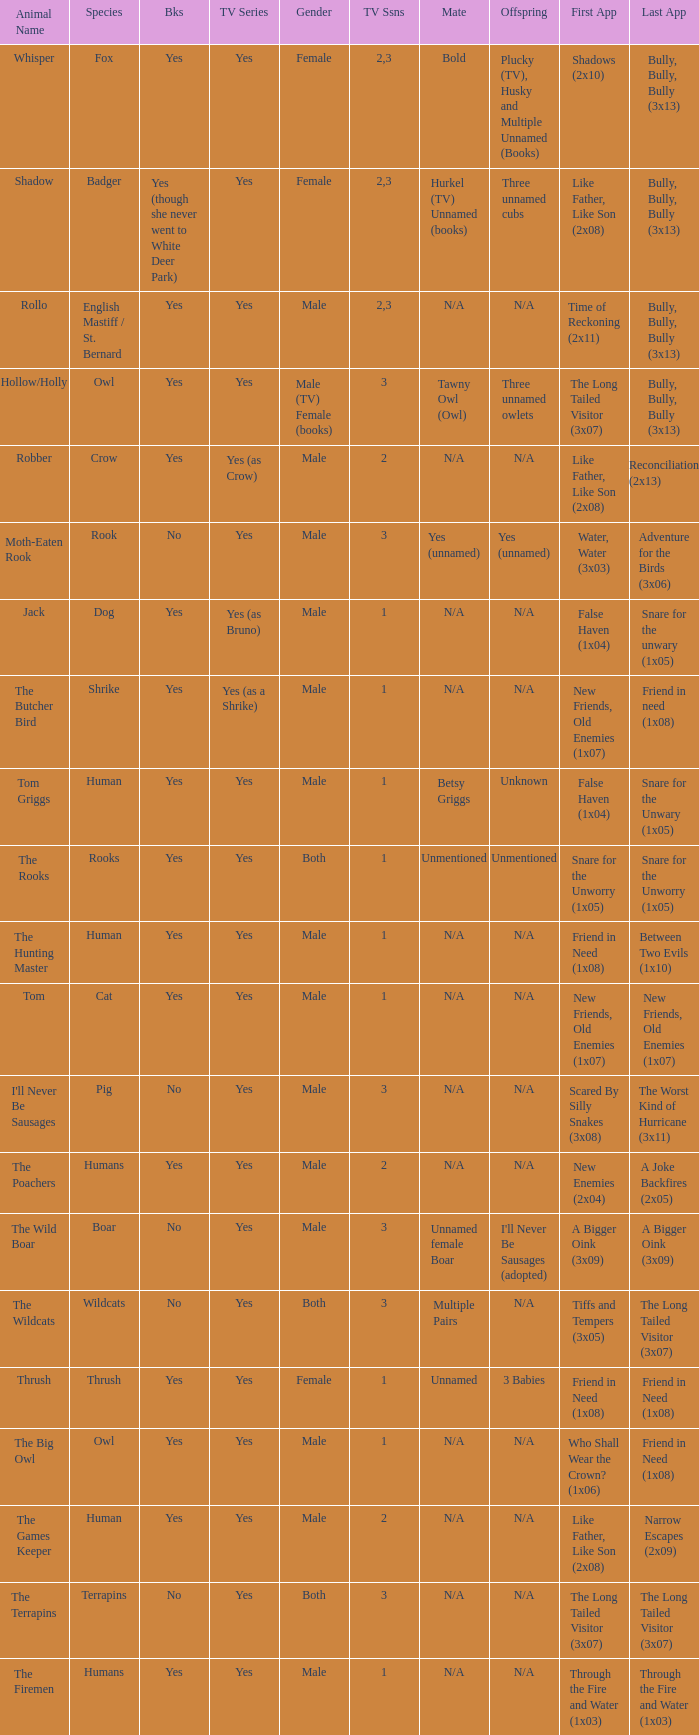I'm looking to parse the entire table for insights. Could you assist me with that? {'header': ['Animal Name', 'Species', 'Bks', 'TV Series', 'Gender', 'TV Ssns', 'Mate', 'Offspring', 'First App', 'Last App'], 'rows': [['Whisper', 'Fox', 'Yes', 'Yes', 'Female', '2,3', 'Bold', 'Plucky (TV), Husky and Multiple Unnamed (Books)', 'Shadows (2x10)', 'Bully, Bully, Bully (3x13)'], ['Shadow', 'Badger', 'Yes (though she never went to White Deer Park)', 'Yes', 'Female', '2,3', 'Hurkel (TV) Unnamed (books)', 'Three unnamed cubs', 'Like Father, Like Son (2x08)', 'Bully, Bully, Bully (3x13)'], ['Rollo', 'English Mastiff / St. Bernard', 'Yes', 'Yes', 'Male', '2,3', 'N/A', 'N/A', 'Time of Reckoning (2x11)', 'Bully, Bully, Bully (3x13)'], ['Hollow/Holly', 'Owl', 'Yes', 'Yes', 'Male (TV) Female (books)', '3', 'Tawny Owl (Owl)', 'Three unnamed owlets', 'The Long Tailed Visitor (3x07)', 'Bully, Bully, Bully (3x13)'], ['Robber', 'Crow', 'Yes', 'Yes (as Crow)', 'Male', '2', 'N/A', 'N/A', 'Like Father, Like Son (2x08)', 'Reconciliation (2x13)'], ['Moth-Eaten Rook', 'Rook', 'No', 'Yes', 'Male', '3', 'Yes (unnamed)', 'Yes (unnamed)', 'Water, Water (3x03)', 'Adventure for the Birds (3x06)'], ['Jack', 'Dog', 'Yes', 'Yes (as Bruno)', 'Male', '1', 'N/A', 'N/A', 'False Haven (1x04)', 'Snare for the unwary (1x05)'], ['The Butcher Bird', 'Shrike', 'Yes', 'Yes (as a Shrike)', 'Male', '1', 'N/A', 'N/A', 'New Friends, Old Enemies (1x07)', 'Friend in need (1x08)'], ['Tom Griggs', 'Human', 'Yes', 'Yes', 'Male', '1', 'Betsy Griggs', 'Unknown', 'False Haven (1x04)', 'Snare for the Unwary (1x05)'], ['The Rooks', 'Rooks', 'Yes', 'Yes', 'Both', '1', 'Unmentioned', 'Unmentioned', 'Snare for the Unworry (1x05)', 'Snare for the Unworry (1x05)'], ['The Hunting Master', 'Human', 'Yes', 'Yes', 'Male', '1', 'N/A', 'N/A', 'Friend in Need (1x08)', 'Between Two Evils (1x10)'], ['Tom', 'Cat', 'Yes', 'Yes', 'Male', '1', 'N/A', 'N/A', 'New Friends, Old Enemies (1x07)', 'New Friends, Old Enemies (1x07)'], ["I'll Never Be Sausages", 'Pig', 'No', 'Yes', 'Male', '3', 'N/A', 'N/A', 'Scared By Silly Snakes (3x08)', 'The Worst Kind of Hurricane (3x11)'], ['The Poachers', 'Humans', 'Yes', 'Yes', 'Male', '2', 'N/A', 'N/A', 'New Enemies (2x04)', 'A Joke Backfires (2x05)'], ['The Wild Boar', 'Boar', 'No', 'Yes', 'Male', '3', 'Unnamed female Boar', "I'll Never Be Sausages (adopted)", 'A Bigger Oink (3x09)', 'A Bigger Oink (3x09)'], ['The Wildcats', 'Wildcats', 'No', 'Yes', 'Both', '3', 'Multiple Pairs', 'N/A', 'Tiffs and Tempers (3x05)', 'The Long Tailed Visitor (3x07)'], ['Thrush', 'Thrush', 'Yes', 'Yes', 'Female', '1', 'Unnamed', '3 Babies', 'Friend in Need (1x08)', 'Friend in Need (1x08)'], ['The Big Owl', 'Owl', 'Yes', 'Yes', 'Male', '1', 'N/A', 'N/A', 'Who Shall Wear the Crown? (1x06)', 'Friend in Need (1x08)'], ['The Games Keeper', 'Human', 'Yes', 'Yes', 'Male', '2', 'N/A', 'N/A', 'Like Father, Like Son (2x08)', 'Narrow Escapes (2x09)'], ['The Terrapins', 'Terrapins', 'No', 'Yes', 'Both', '3', 'N/A', 'N/A', 'The Long Tailed Visitor (3x07)', 'The Long Tailed Visitor (3x07)'], ['The Firemen', 'Humans', 'Yes', 'Yes', 'Male', '1', 'N/A', 'N/A', 'Through the Fire and Water (1x03)', 'Through the Fire and Water (1x03)']]} What species was approved for tv show and was a terrapins? The Terrapins. 